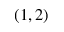<formula> <loc_0><loc_0><loc_500><loc_500>( 1 , 2 )</formula> 